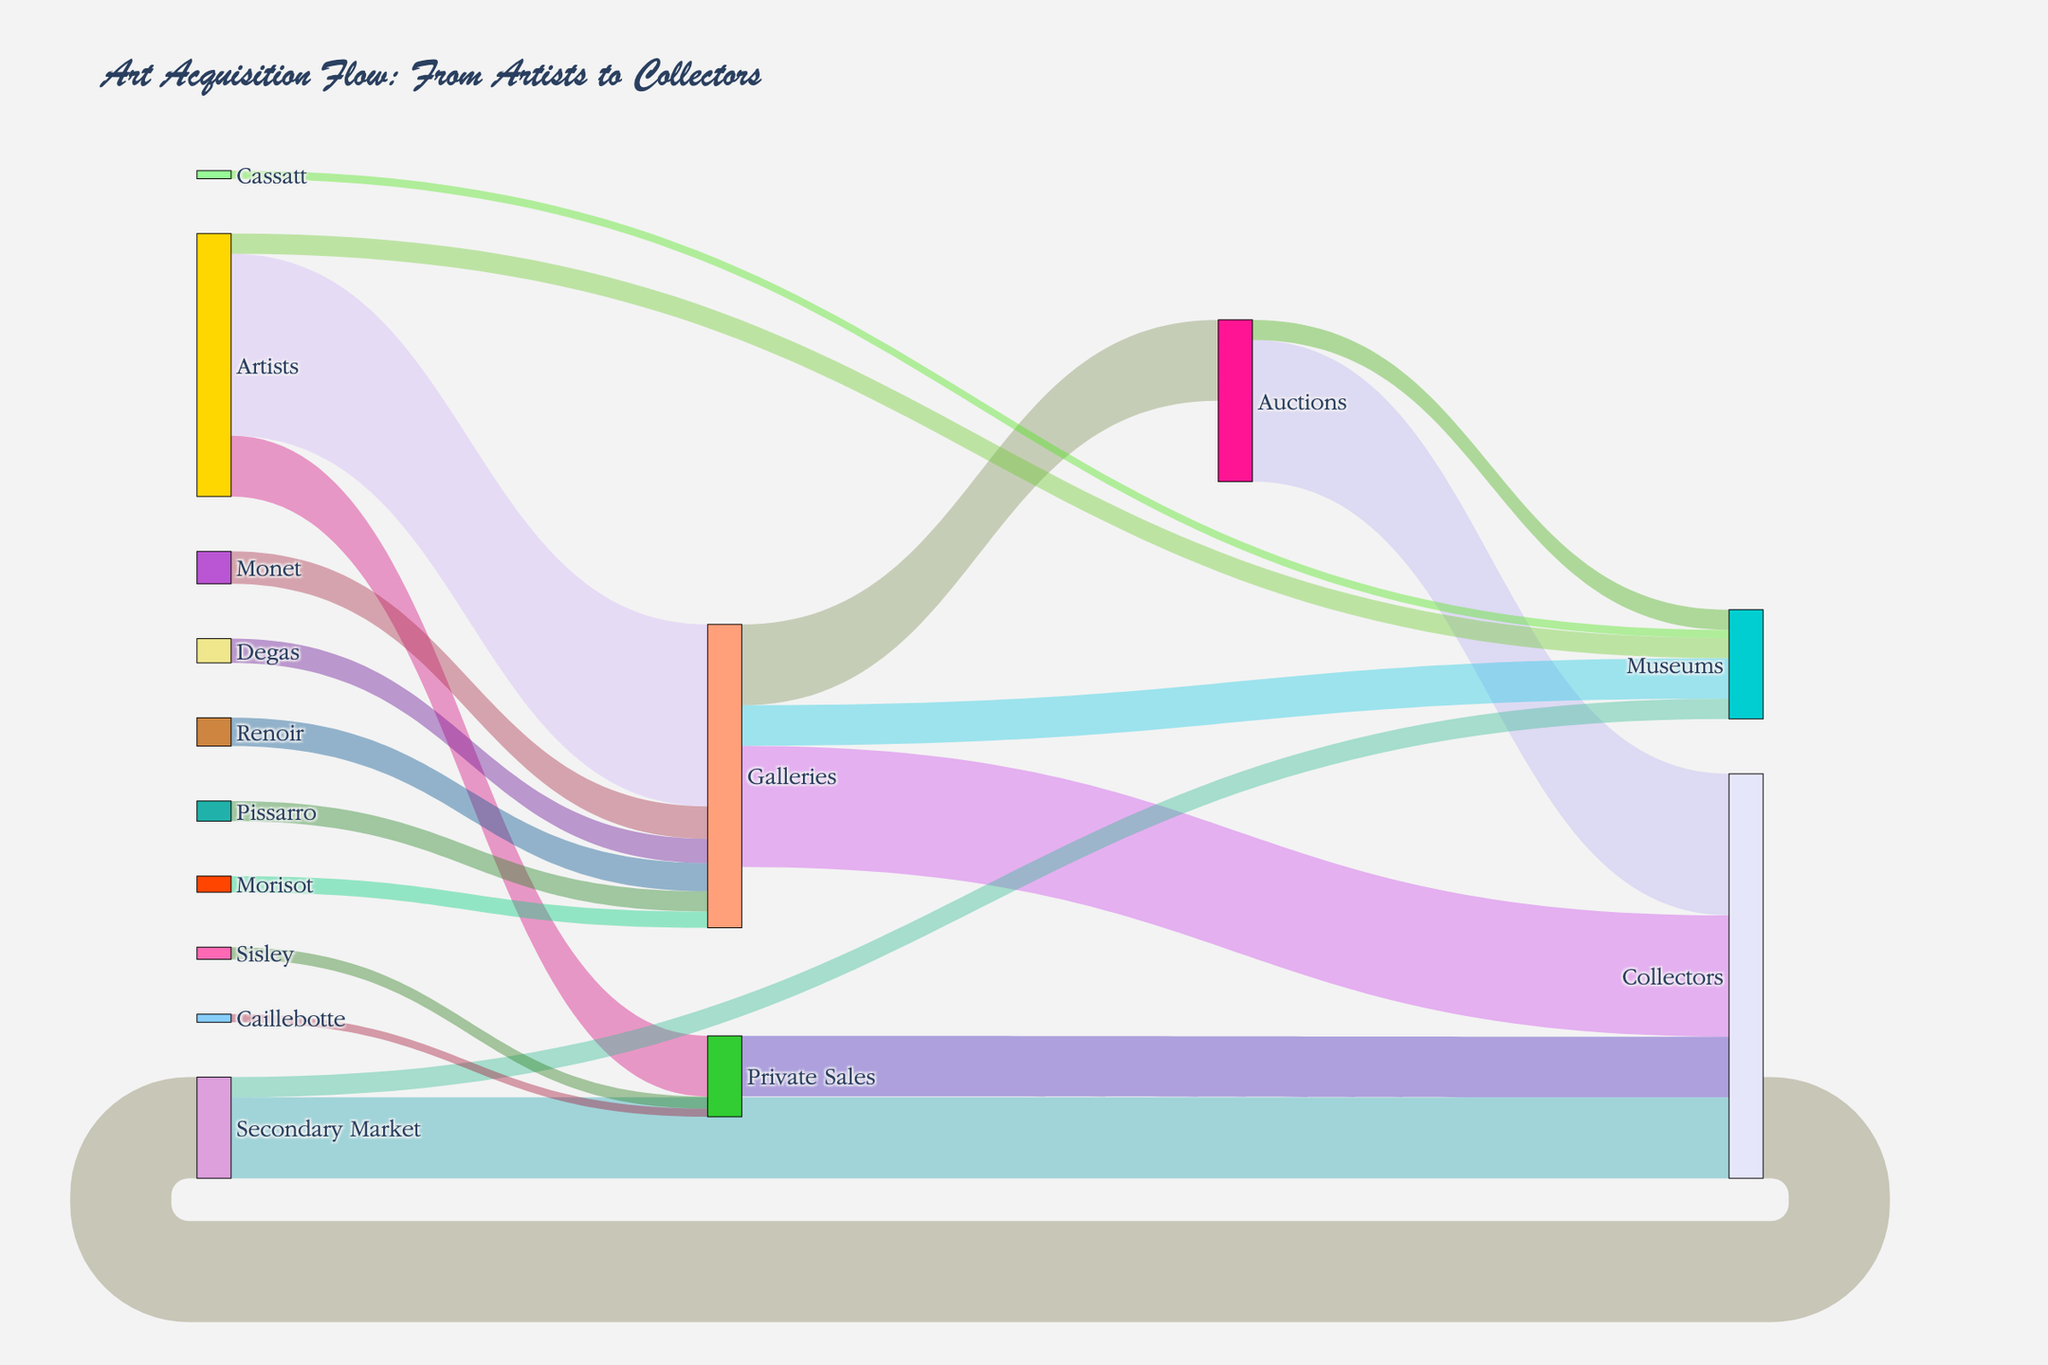What is the flow value from Auctions to Collectors? The flow value from "Auctions" to "Collectors" can be directly observed in the figure by tracing the link from the "Auctions" node to the "Collectors" node. The value is displayed on the link, which is 35.
Answer: 35 How many artworks flow from Artists to Museums in total? To determine the total flow from "Artists" to "Museums," you must sum the direct flow "Artists -> Museums" and any indirect flows via other nodes. The direct flow is 5. Summing up the direct value, we get 5.
Answer: 5 Which path has the largest flow value going to Collectors? To find the path with the largest flow value going to "Collectors," compare the flow values of all incoming links to the "Collectors" node: "Galleries -> Collectors" (30), "Auctions -> Collectors" (35), "Private Sales -> Collectors" (15), and "Secondary Market -> Collectors" (20). The largest value is from "Auctions."
Answer: Auctions What is the total number of artworks flowing into Museums? To calculate the total number of artworks flowing into Museums, sum all link values going to the "Museums" node: "Galleries -> Museums" (10), "Auctions -> Museums" (5), "Artists -> Museums" (5), and "Secondary Market -> Museums" (5). The total sum is 10 + 5 + 5 + 5 = 25.
Answer: 25 What is the smallest flow value from the list of famous Impressionist painters? To find the smallest flow value from the list of famous Impressionist painters (Monet, Renoir, Degas, Pissarro, Morisot, Sisley, Caillebotte, Cassatt), we look at their respective link values: Monet (8), Renoir (7), Degas (6), Pissarro (5), Morisot (4), Sisley (3), Caillebotte (2), Cassatt (2). The smallest value is 2 (Caillebotte and Cassatt).
Answer: 2 How does the total flow from Galleries compare to the total flow from Private Sales? To compare the total flow from "Galleries" and "Private Sales," sum the outgoing flows from each node. Galleries' total outgoing flows: 20 (to Auctions) + 30 (to Collectors) + 10 (to Museums) = 60. Private Sales' total outgoing flow: 15 (to Collectors) = 15. The total from Galleries is larger.
Answer: Galleries Which artist has the highest flow through Galleries? To identify which artist has the highest flow through "Galleries," check the flow values for each artist to the Galleries: Monet (8), Renoir (7), Degas (6), Pissarro (5), Morisot (4). The highest value is for Monet.
Answer: Monet What is the combined flow value from all sources to the Secondary Market? To find the combined flow value from all sources to the Secondary Market, identify and sum all links leading to the "Secondary Market" node. Only "Collectors" contribute to the flow with a value of 25. The combined value is 25.
Answer: 25 